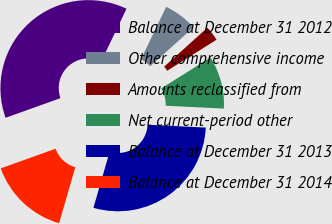Convert chart to OTSL. <chart><loc_0><loc_0><loc_500><loc_500><pie_chart><fcel>Balance at December 31 2012<fcel>Other comprehensive income<fcel>Amounts reclassified from<fcel>Net current-period other<fcel>Balance at December 31 2013<fcel>Balance at December 31 2014<nl><fcel>37.59%<fcel>6.22%<fcel>2.73%<fcel>9.71%<fcel>28.71%<fcel>15.04%<nl></chart> 